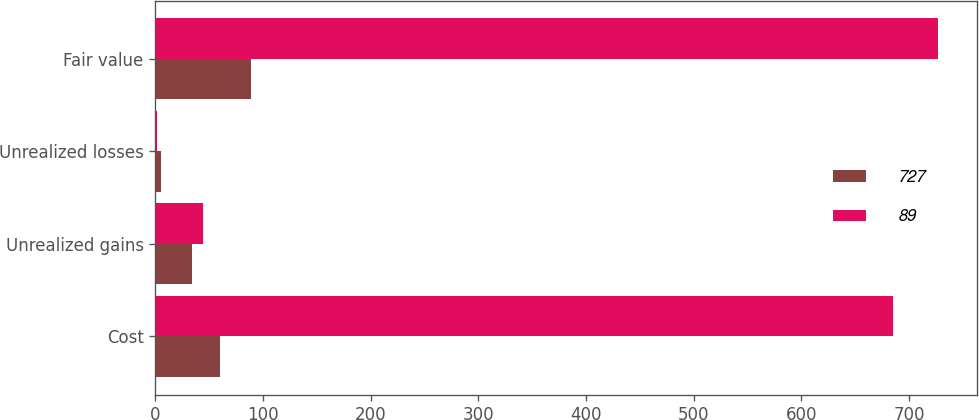<chart> <loc_0><loc_0><loc_500><loc_500><stacked_bar_chart><ecel><fcel>Cost<fcel>Unrealized gains<fcel>Unrealized losses<fcel>Fair value<nl><fcel>727<fcel>60<fcel>34<fcel>5<fcel>89<nl><fcel>89<fcel>685<fcel>44<fcel>2<fcel>727<nl></chart> 